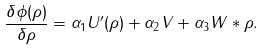Convert formula to latex. <formula><loc_0><loc_0><loc_500><loc_500>\frac { \delta \phi ( \rho ) } { \delta \rho } = \alpha _ { 1 } U ^ { \prime } ( \rho ) + \alpha _ { 2 } V + \alpha _ { 3 } W * \rho .</formula> 